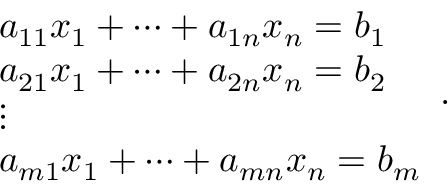<formula> <loc_0><loc_0><loc_500><loc_500>{ \begin{array} { l } { a _ { 1 1 } x _ { 1 } + \cdots + a _ { 1 n } x _ { n } = b _ { 1 } } \\ { a _ { 2 1 } x _ { 1 } + \cdots + a _ { 2 n } x _ { n } = b _ { 2 } } \\ { \vdots } \\ { a _ { m 1 } x _ { 1 } + \cdots + a _ { m n } x _ { n } = b _ { m } } \end{array} } .</formula> 